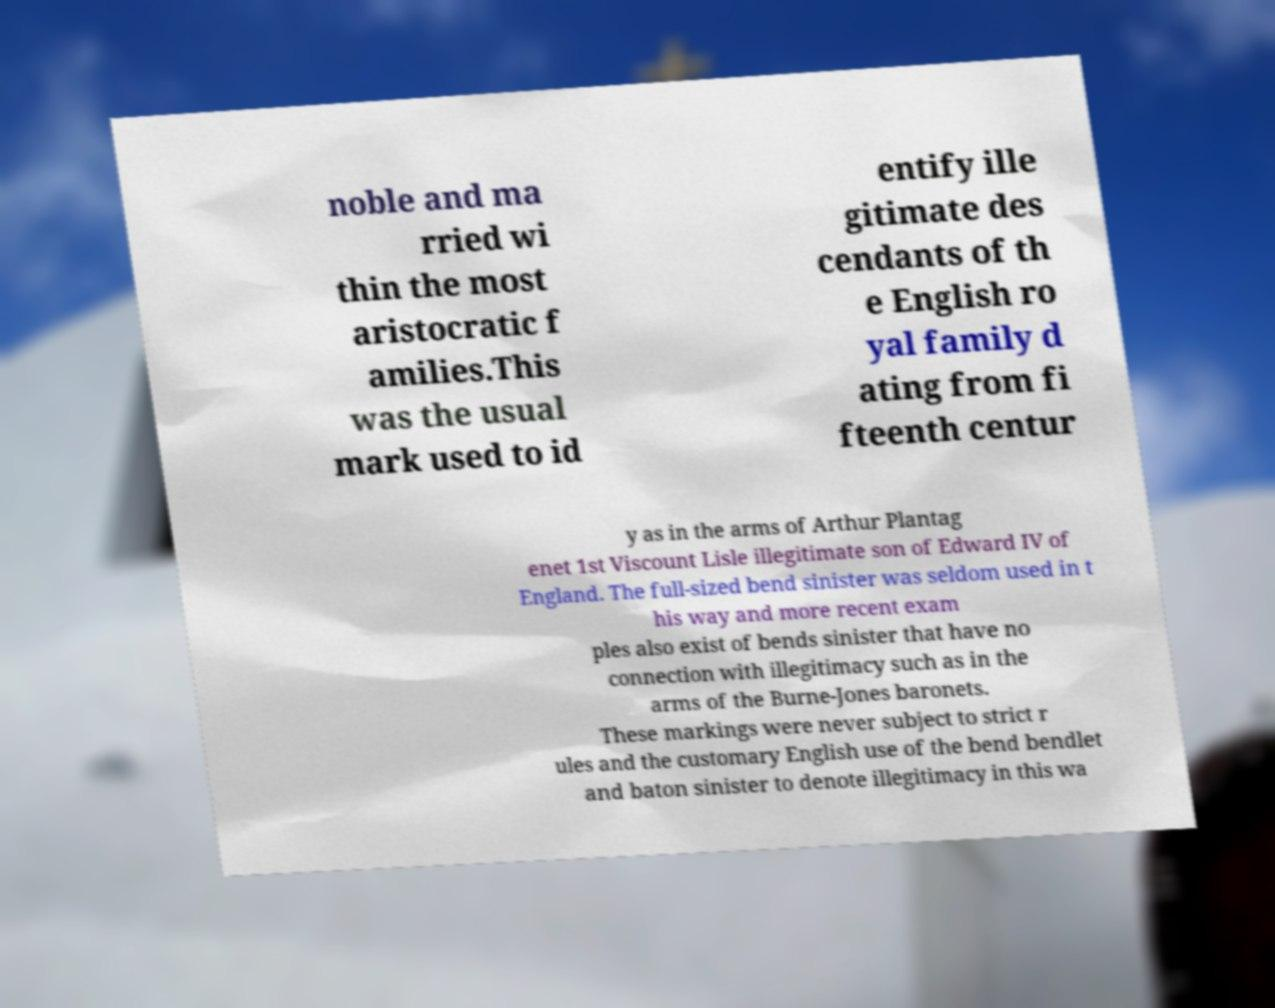Please identify and transcribe the text found in this image. noble and ma rried wi thin the most aristocratic f amilies.This was the usual mark used to id entify ille gitimate des cendants of th e English ro yal family d ating from fi fteenth centur y as in the arms of Arthur Plantag enet 1st Viscount Lisle illegitimate son of Edward IV of England. The full-sized bend sinister was seldom used in t his way and more recent exam ples also exist of bends sinister that have no connection with illegitimacy such as in the arms of the Burne-Jones baronets. These markings were never subject to strict r ules and the customary English use of the bend bendlet and baton sinister to denote illegitimacy in this wa 